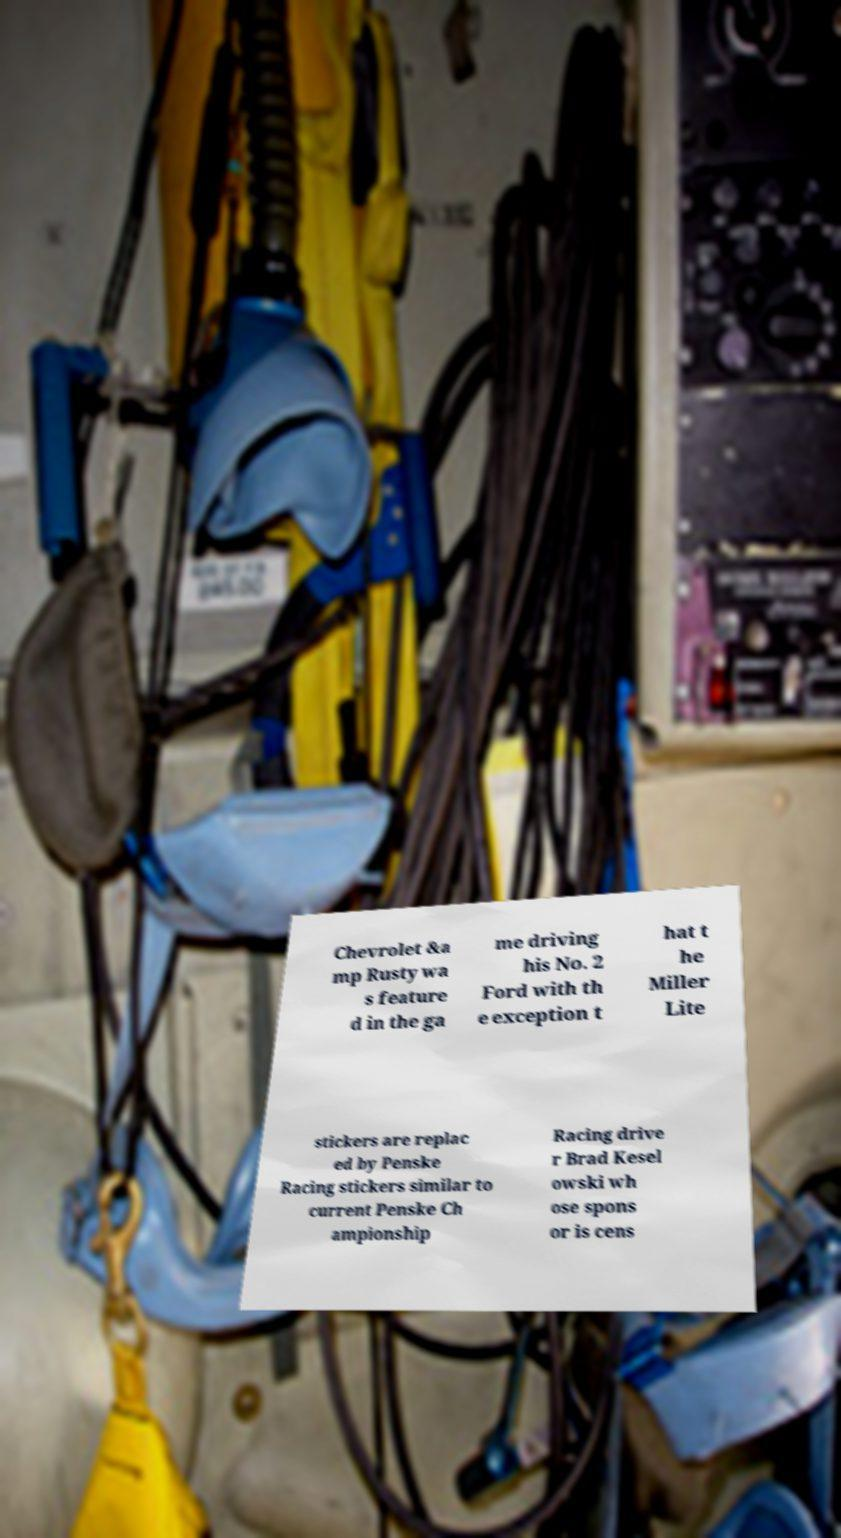Please read and relay the text visible in this image. What does it say? Chevrolet &a mp Rusty wa s feature d in the ga me driving his No. 2 Ford with th e exception t hat t he Miller Lite stickers are replac ed by Penske Racing stickers similar to current Penske Ch ampionship Racing drive r Brad Kesel owski wh ose spons or is cens 